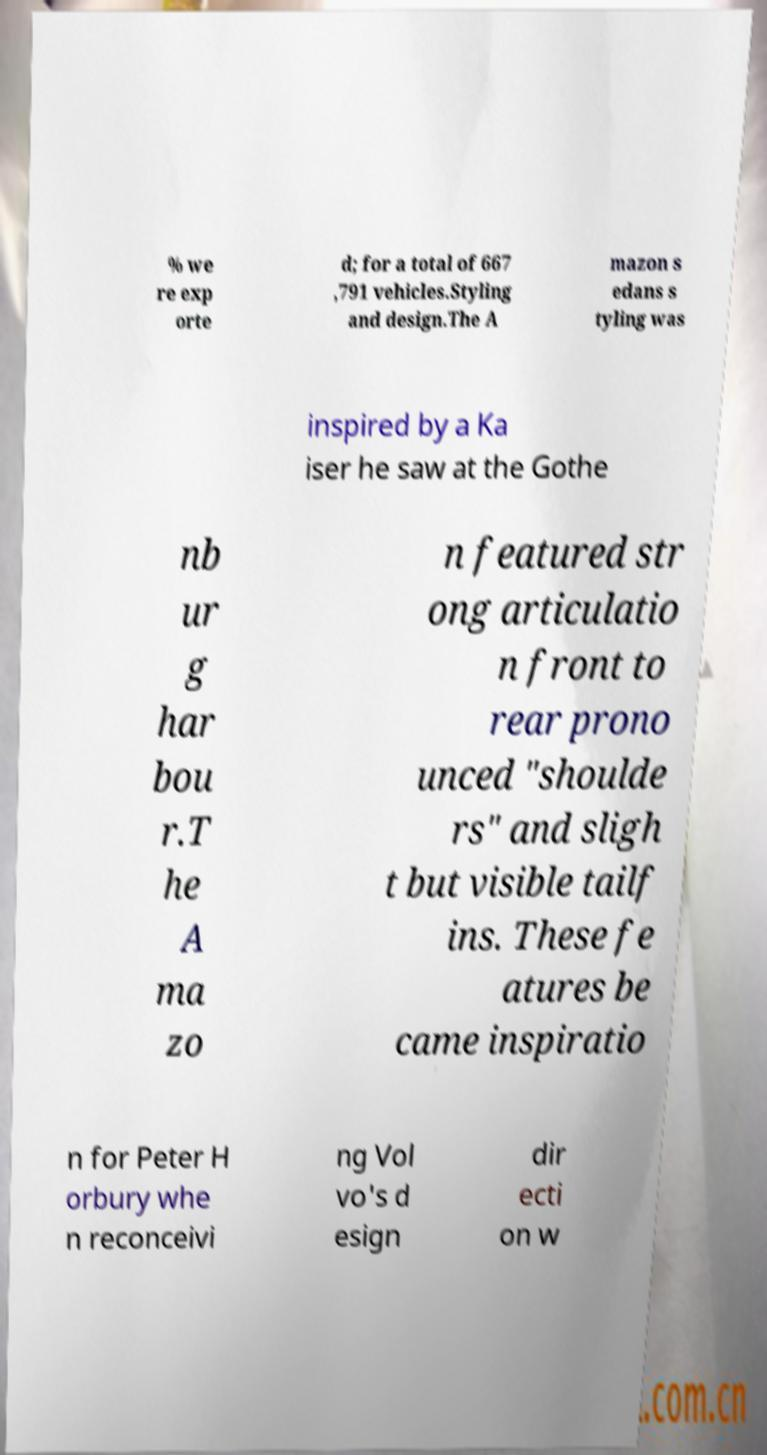Could you assist in decoding the text presented in this image and type it out clearly? % we re exp orte d; for a total of 667 ,791 vehicles.Styling and design.The A mazon s edans s tyling was inspired by a Ka iser he saw at the Gothe nb ur g har bou r.T he A ma zo n featured str ong articulatio n front to rear prono unced "shoulde rs" and sligh t but visible tailf ins. These fe atures be came inspiratio n for Peter H orbury whe n reconceivi ng Vol vo's d esign dir ecti on w 